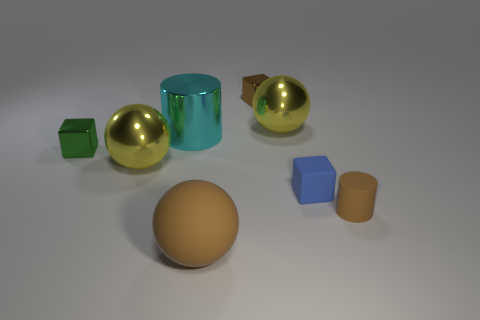There is a metal block to the left of the large yellow thing that is in front of the green block; what is its size?
Your answer should be compact. Small. What shape is the small brown object behind the large metallic object in front of the tiny metal thing left of the large brown matte thing?
Offer a terse response. Cube. There is a brown cylinder that is made of the same material as the brown ball; what size is it?
Offer a terse response. Small. Are there more metal cubes than big objects?
Provide a short and direct response. No. What material is the brown cube that is the same size as the green thing?
Offer a terse response. Metal. Do the cyan cylinder behind the green cube and the tiny brown cube have the same size?
Your answer should be compact. No. What number of cylinders are either yellow shiny things or large rubber objects?
Offer a very short reply. 0. There is a big yellow sphere in front of the green thing; what is it made of?
Make the answer very short. Metal. Are there fewer tiny green cubes than small blue balls?
Make the answer very short. No. There is a cube that is right of the brown sphere and in front of the large cyan metal cylinder; what is its size?
Your answer should be compact. Small. 